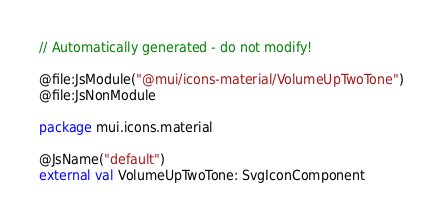Convert code to text. <code><loc_0><loc_0><loc_500><loc_500><_Kotlin_>// Automatically generated - do not modify!

@file:JsModule("@mui/icons-material/VolumeUpTwoTone")
@file:JsNonModule

package mui.icons.material

@JsName("default")
external val VolumeUpTwoTone: SvgIconComponent
</code> 